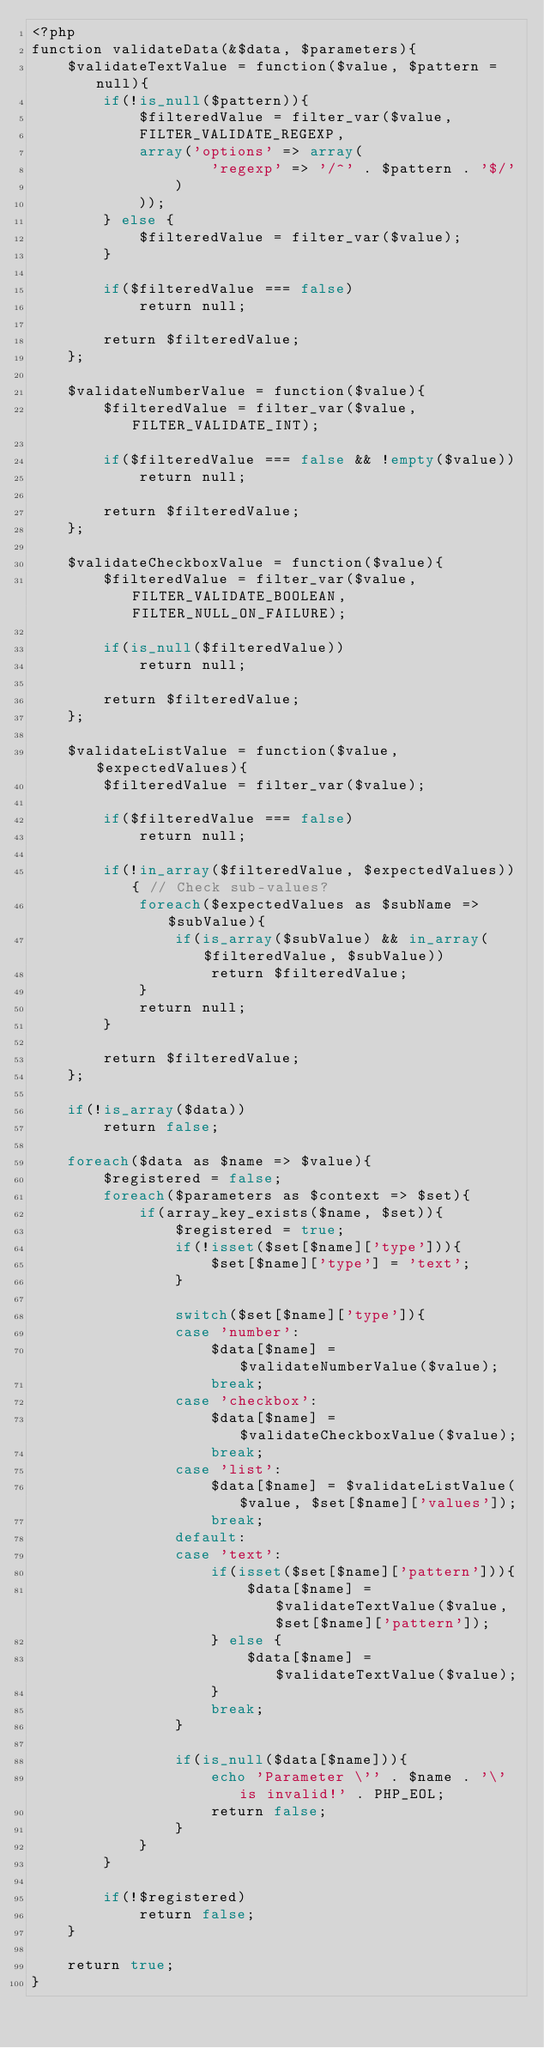Convert code to text. <code><loc_0><loc_0><loc_500><loc_500><_PHP_><?php
function validateData(&$data, $parameters){
	$validateTextValue = function($value, $pattern = null){
		if(!is_null($pattern)){
			$filteredValue = filter_var($value,
			FILTER_VALIDATE_REGEXP,
			array('options' => array(
					'regexp' => '/^' . $pattern . '$/'
				)
			));
		} else {
			$filteredValue = filter_var($value);
		}

		if($filteredValue === false)
			return null;

		return $filteredValue;
	};

	$validateNumberValue = function($value){
		$filteredValue = filter_var($value, FILTER_VALIDATE_INT);

		if($filteredValue === false && !empty($value))
			return null;

		return $filteredValue;
	};

	$validateCheckboxValue = function($value){
		$filteredValue = filter_var($value, FILTER_VALIDATE_BOOLEAN, FILTER_NULL_ON_FAILURE);

		if(is_null($filteredValue))
			return null;

		return $filteredValue;
	};

	$validateListValue = function($value, $expectedValues){
		$filteredValue = filter_var($value);

		if($filteredValue === false)
			return null;

		if(!in_array($filteredValue, $expectedValues)){ // Check sub-values?
			foreach($expectedValues as $subName => $subValue){
				if(is_array($subValue) && in_array($filteredValue, $subValue))
					return $filteredValue;
			}
			return null;
		}

		return $filteredValue;
	};

	if(!is_array($data))
		return false;

	foreach($data as $name => $value){
		$registered = false;
		foreach($parameters as $context => $set){
			if(array_key_exists($name, $set)){
				$registered = true;
				if(!isset($set[$name]['type'])){
					$set[$name]['type'] = 'text';
				}

				switch($set[$name]['type']){
				case 'number':
					$data[$name] = $validateNumberValue($value);
					break;
				case 'checkbox':
					$data[$name] = $validateCheckboxValue($value);
					break;
				case 'list':
					$data[$name] = $validateListValue($value, $set[$name]['values']);
					break;
				default:
				case 'text':
					if(isset($set[$name]['pattern'])){
						$data[$name] = $validateTextValue($value, $set[$name]['pattern']);
					} else {
						$data[$name] = $validateTextValue($value);
					}
					break;
				}

				if(is_null($data[$name])){
					echo 'Parameter \'' . $name . '\' is invalid!' . PHP_EOL;
					return false;
				}
			}
		}

		if(!$registered)
			return false;
	}

	return true;
}
</code> 